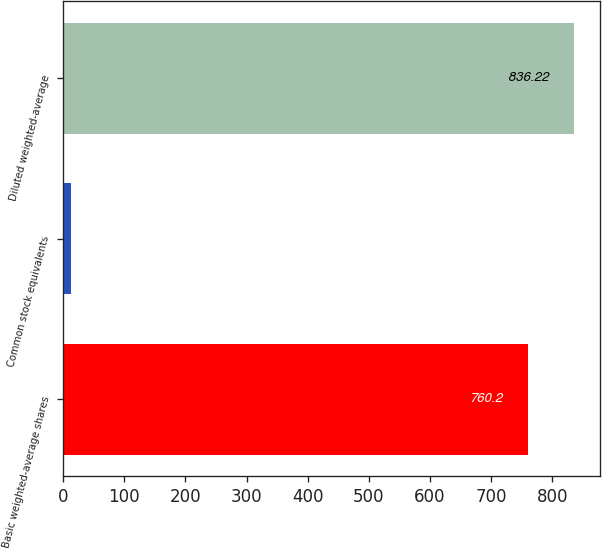<chart> <loc_0><loc_0><loc_500><loc_500><bar_chart><fcel>Basic weighted-average shares<fcel>Common stock equivalents<fcel>Diluted weighted-average<nl><fcel>760.2<fcel>12.7<fcel>836.22<nl></chart> 